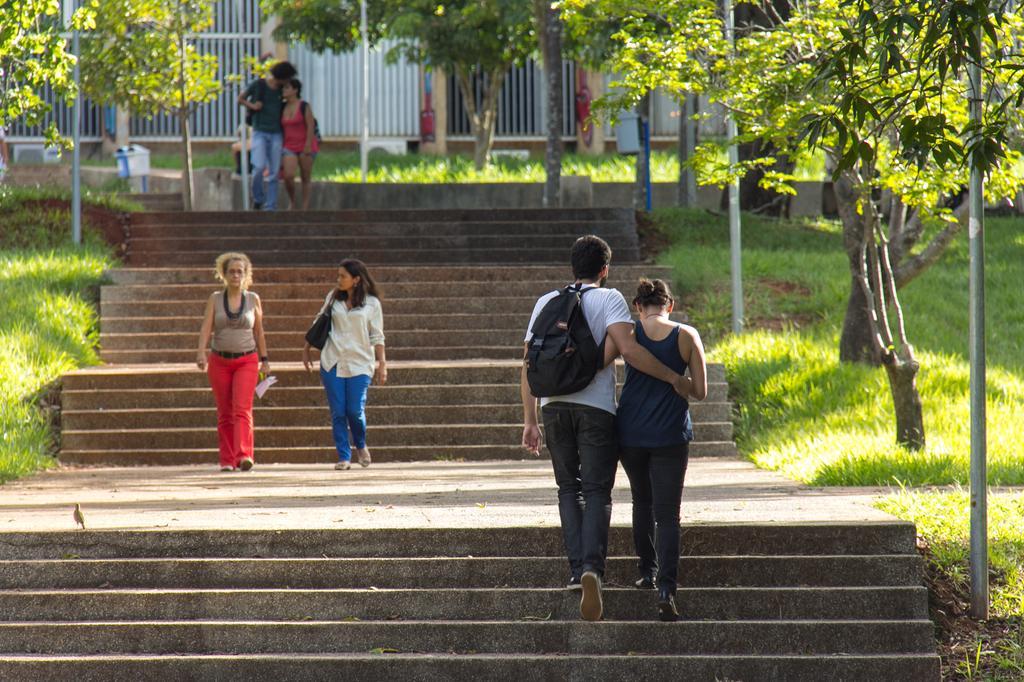Describe this image in one or two sentences. There are people walking and these two people carrying bags. We can see steps, grass, poles and trees. In the background we can see grills and AC outlets. 